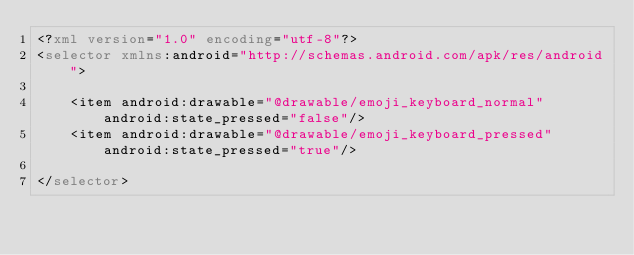Convert code to text. <code><loc_0><loc_0><loc_500><loc_500><_XML_><?xml version="1.0" encoding="utf-8"?>
<selector xmlns:android="http://schemas.android.com/apk/res/android">

    <item android:drawable="@drawable/emoji_keyboard_normal" android:state_pressed="false"/>
    <item android:drawable="@drawable/emoji_keyboard_pressed" android:state_pressed="true"/>

</selector></code> 